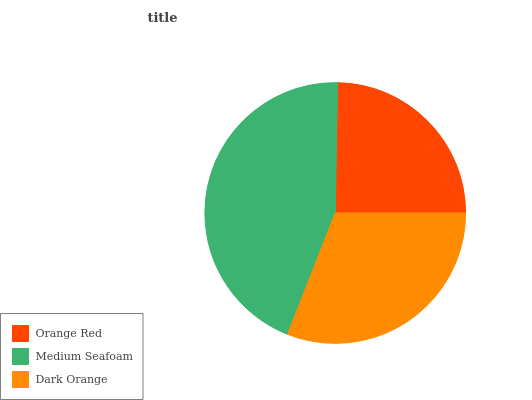Is Orange Red the minimum?
Answer yes or no. Yes. Is Medium Seafoam the maximum?
Answer yes or no. Yes. Is Dark Orange the minimum?
Answer yes or no. No. Is Dark Orange the maximum?
Answer yes or no. No. Is Medium Seafoam greater than Dark Orange?
Answer yes or no. Yes. Is Dark Orange less than Medium Seafoam?
Answer yes or no. Yes. Is Dark Orange greater than Medium Seafoam?
Answer yes or no. No. Is Medium Seafoam less than Dark Orange?
Answer yes or no. No. Is Dark Orange the high median?
Answer yes or no. Yes. Is Dark Orange the low median?
Answer yes or no. Yes. Is Medium Seafoam the high median?
Answer yes or no. No. Is Orange Red the low median?
Answer yes or no. No. 